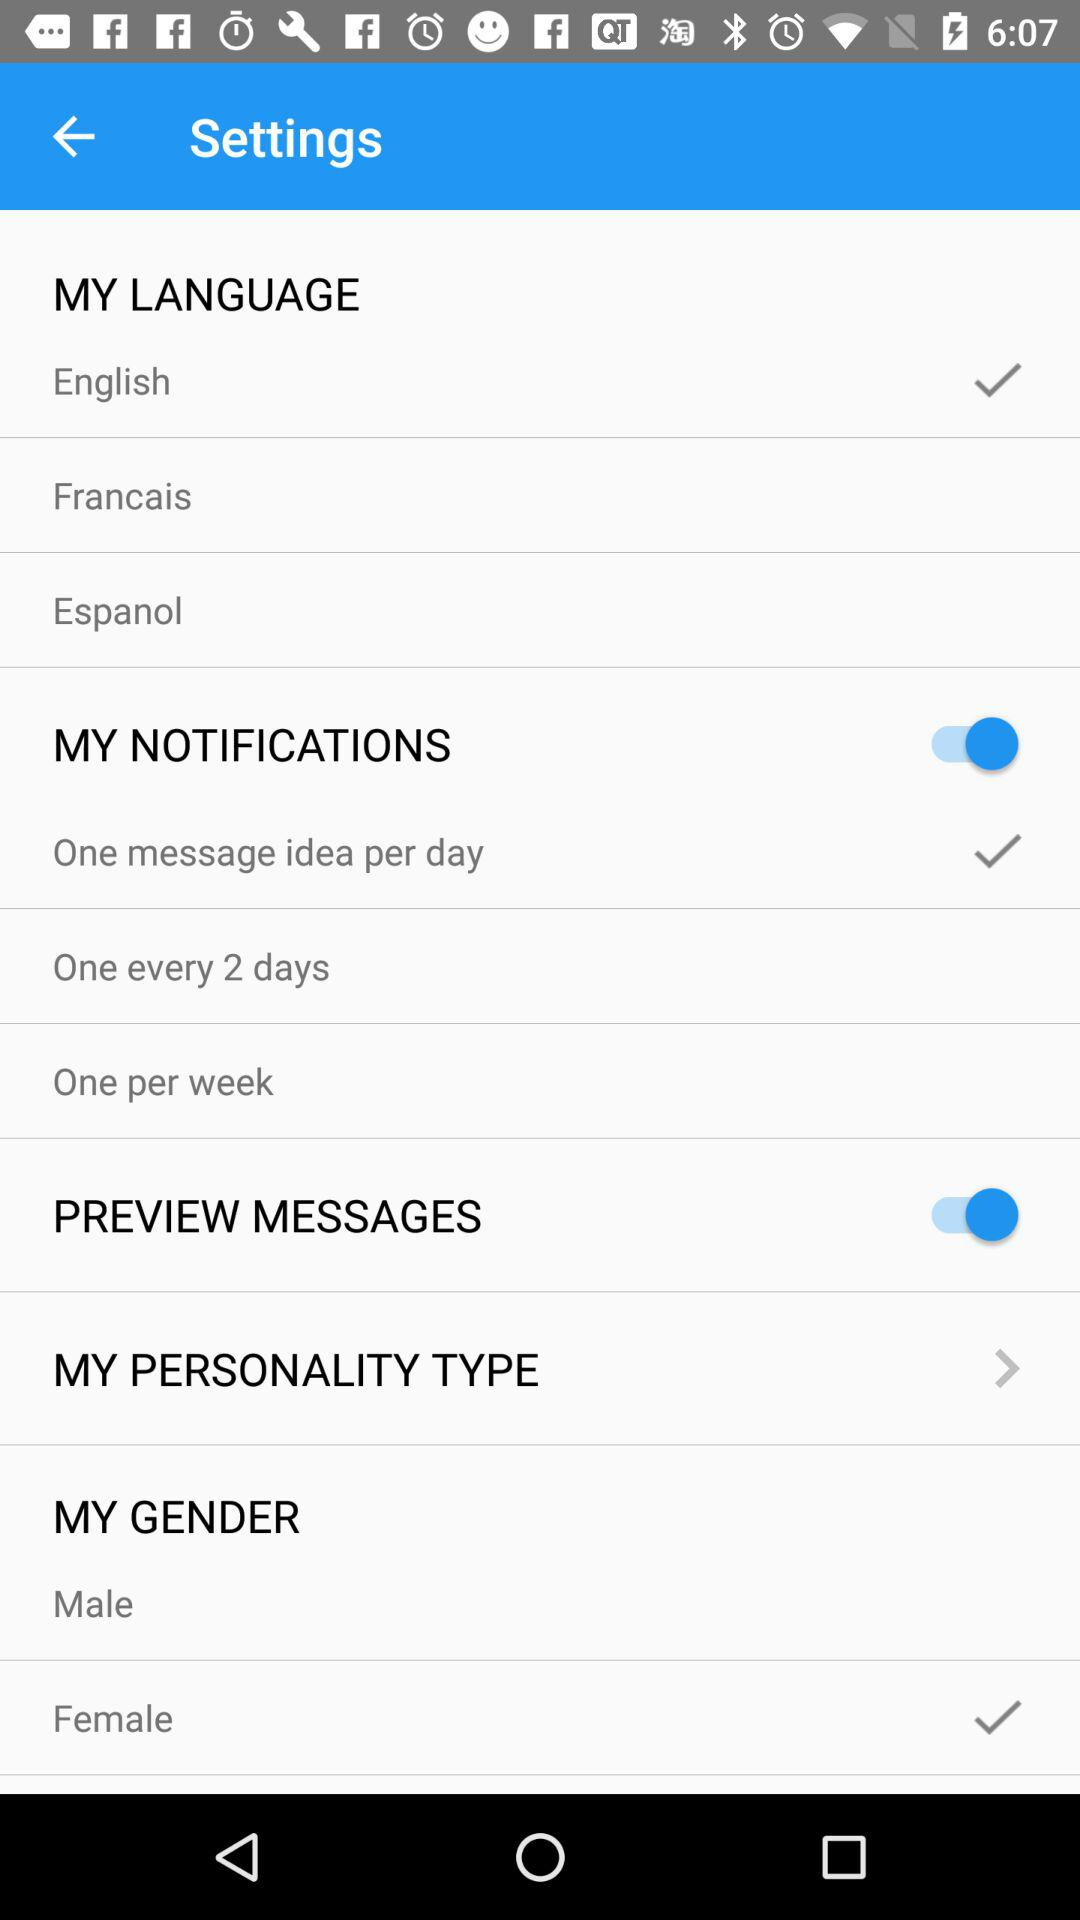How many languages are available to choose from?
Answer the question using a single word or phrase. 3 